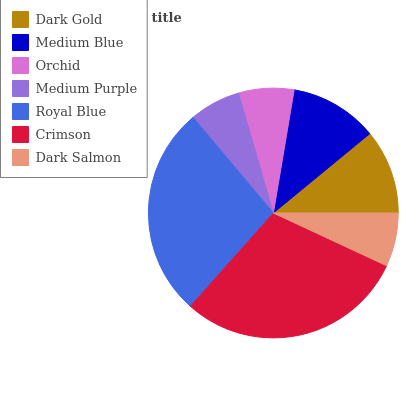Is Medium Purple the minimum?
Answer yes or no. Yes. Is Crimson the maximum?
Answer yes or no. Yes. Is Medium Blue the minimum?
Answer yes or no. No. Is Medium Blue the maximum?
Answer yes or no. No. Is Medium Blue greater than Dark Gold?
Answer yes or no. Yes. Is Dark Gold less than Medium Blue?
Answer yes or no. Yes. Is Dark Gold greater than Medium Blue?
Answer yes or no. No. Is Medium Blue less than Dark Gold?
Answer yes or no. No. Is Dark Gold the high median?
Answer yes or no. Yes. Is Dark Gold the low median?
Answer yes or no. Yes. Is Crimson the high median?
Answer yes or no. No. Is Dark Salmon the low median?
Answer yes or no. No. 